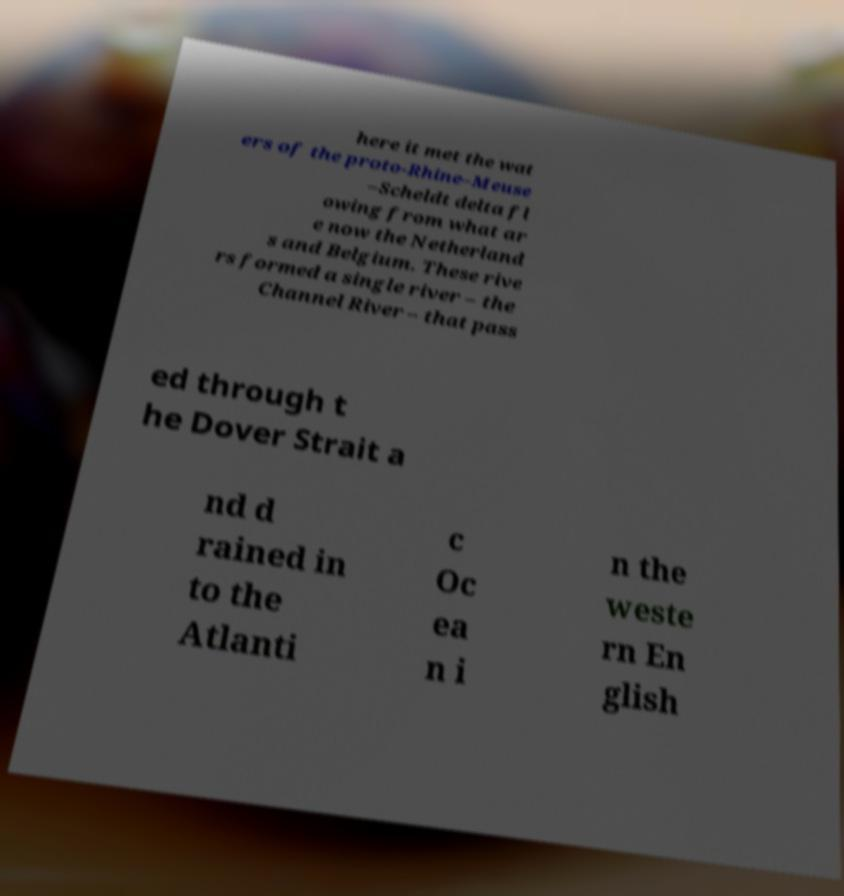For documentation purposes, I need the text within this image transcribed. Could you provide that? here it met the wat ers of the proto-Rhine–Meuse –Scheldt delta fl owing from what ar e now the Netherland s and Belgium. These rive rs formed a single river – the Channel River – that pass ed through t he Dover Strait a nd d rained in to the Atlanti c Oc ea n i n the weste rn En glish 